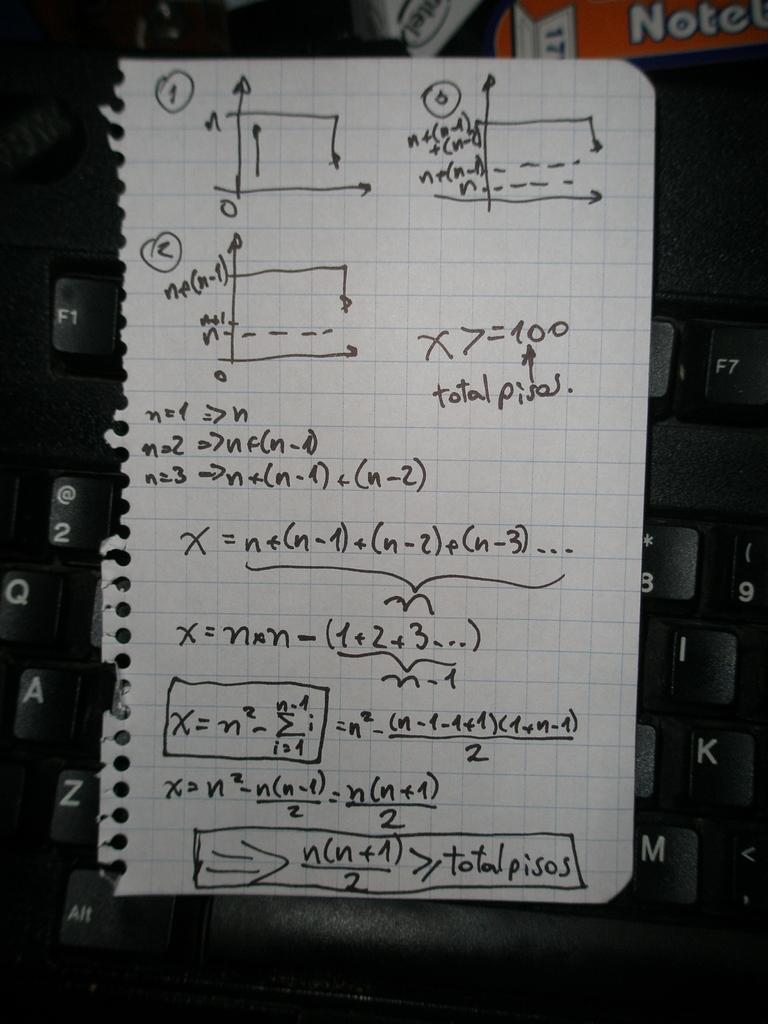What is the main object in the center of the image? There is a keyboard in the center of the image. What else can be seen in the image besides the keyboard? There is a banner and a paper in the image. What is written on the paper? Something is written on the paper, but the specific content is not mentioned in the facts. What type of scent can be detected from the cart in the image? There is no cart present in the image, so it is not possible to determine any scent. 